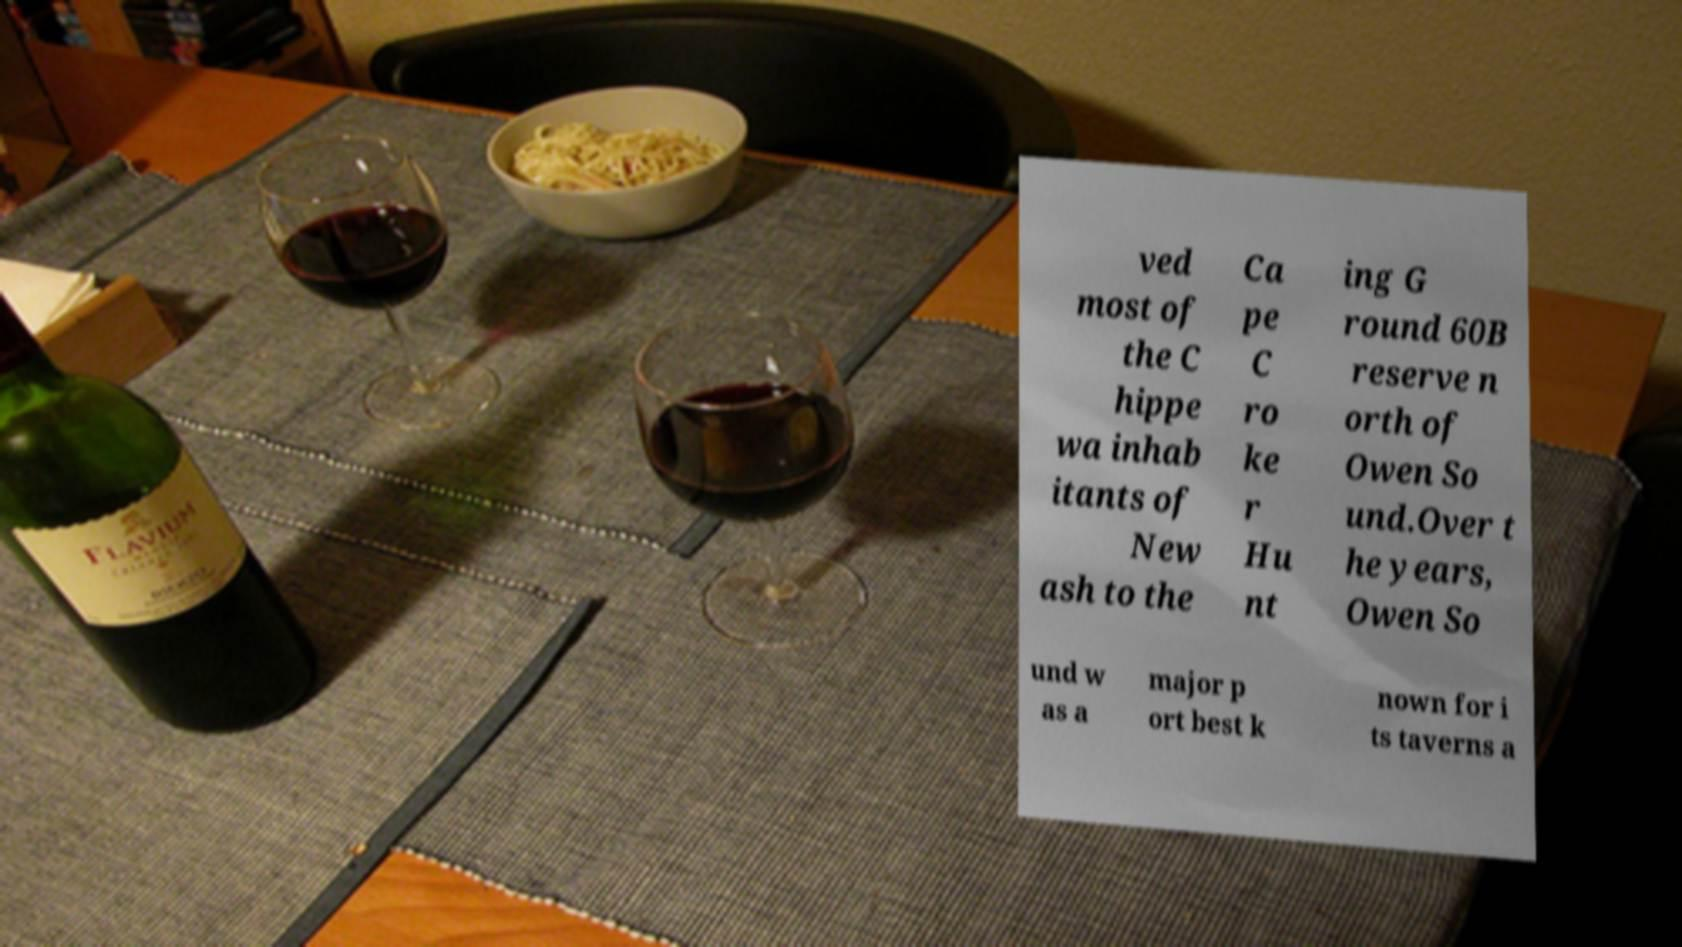Please read and relay the text visible in this image. What does it say? ved most of the C hippe wa inhab itants of New ash to the Ca pe C ro ke r Hu nt ing G round 60B reserve n orth of Owen So und.Over t he years, Owen So und w as a major p ort best k nown for i ts taverns a 